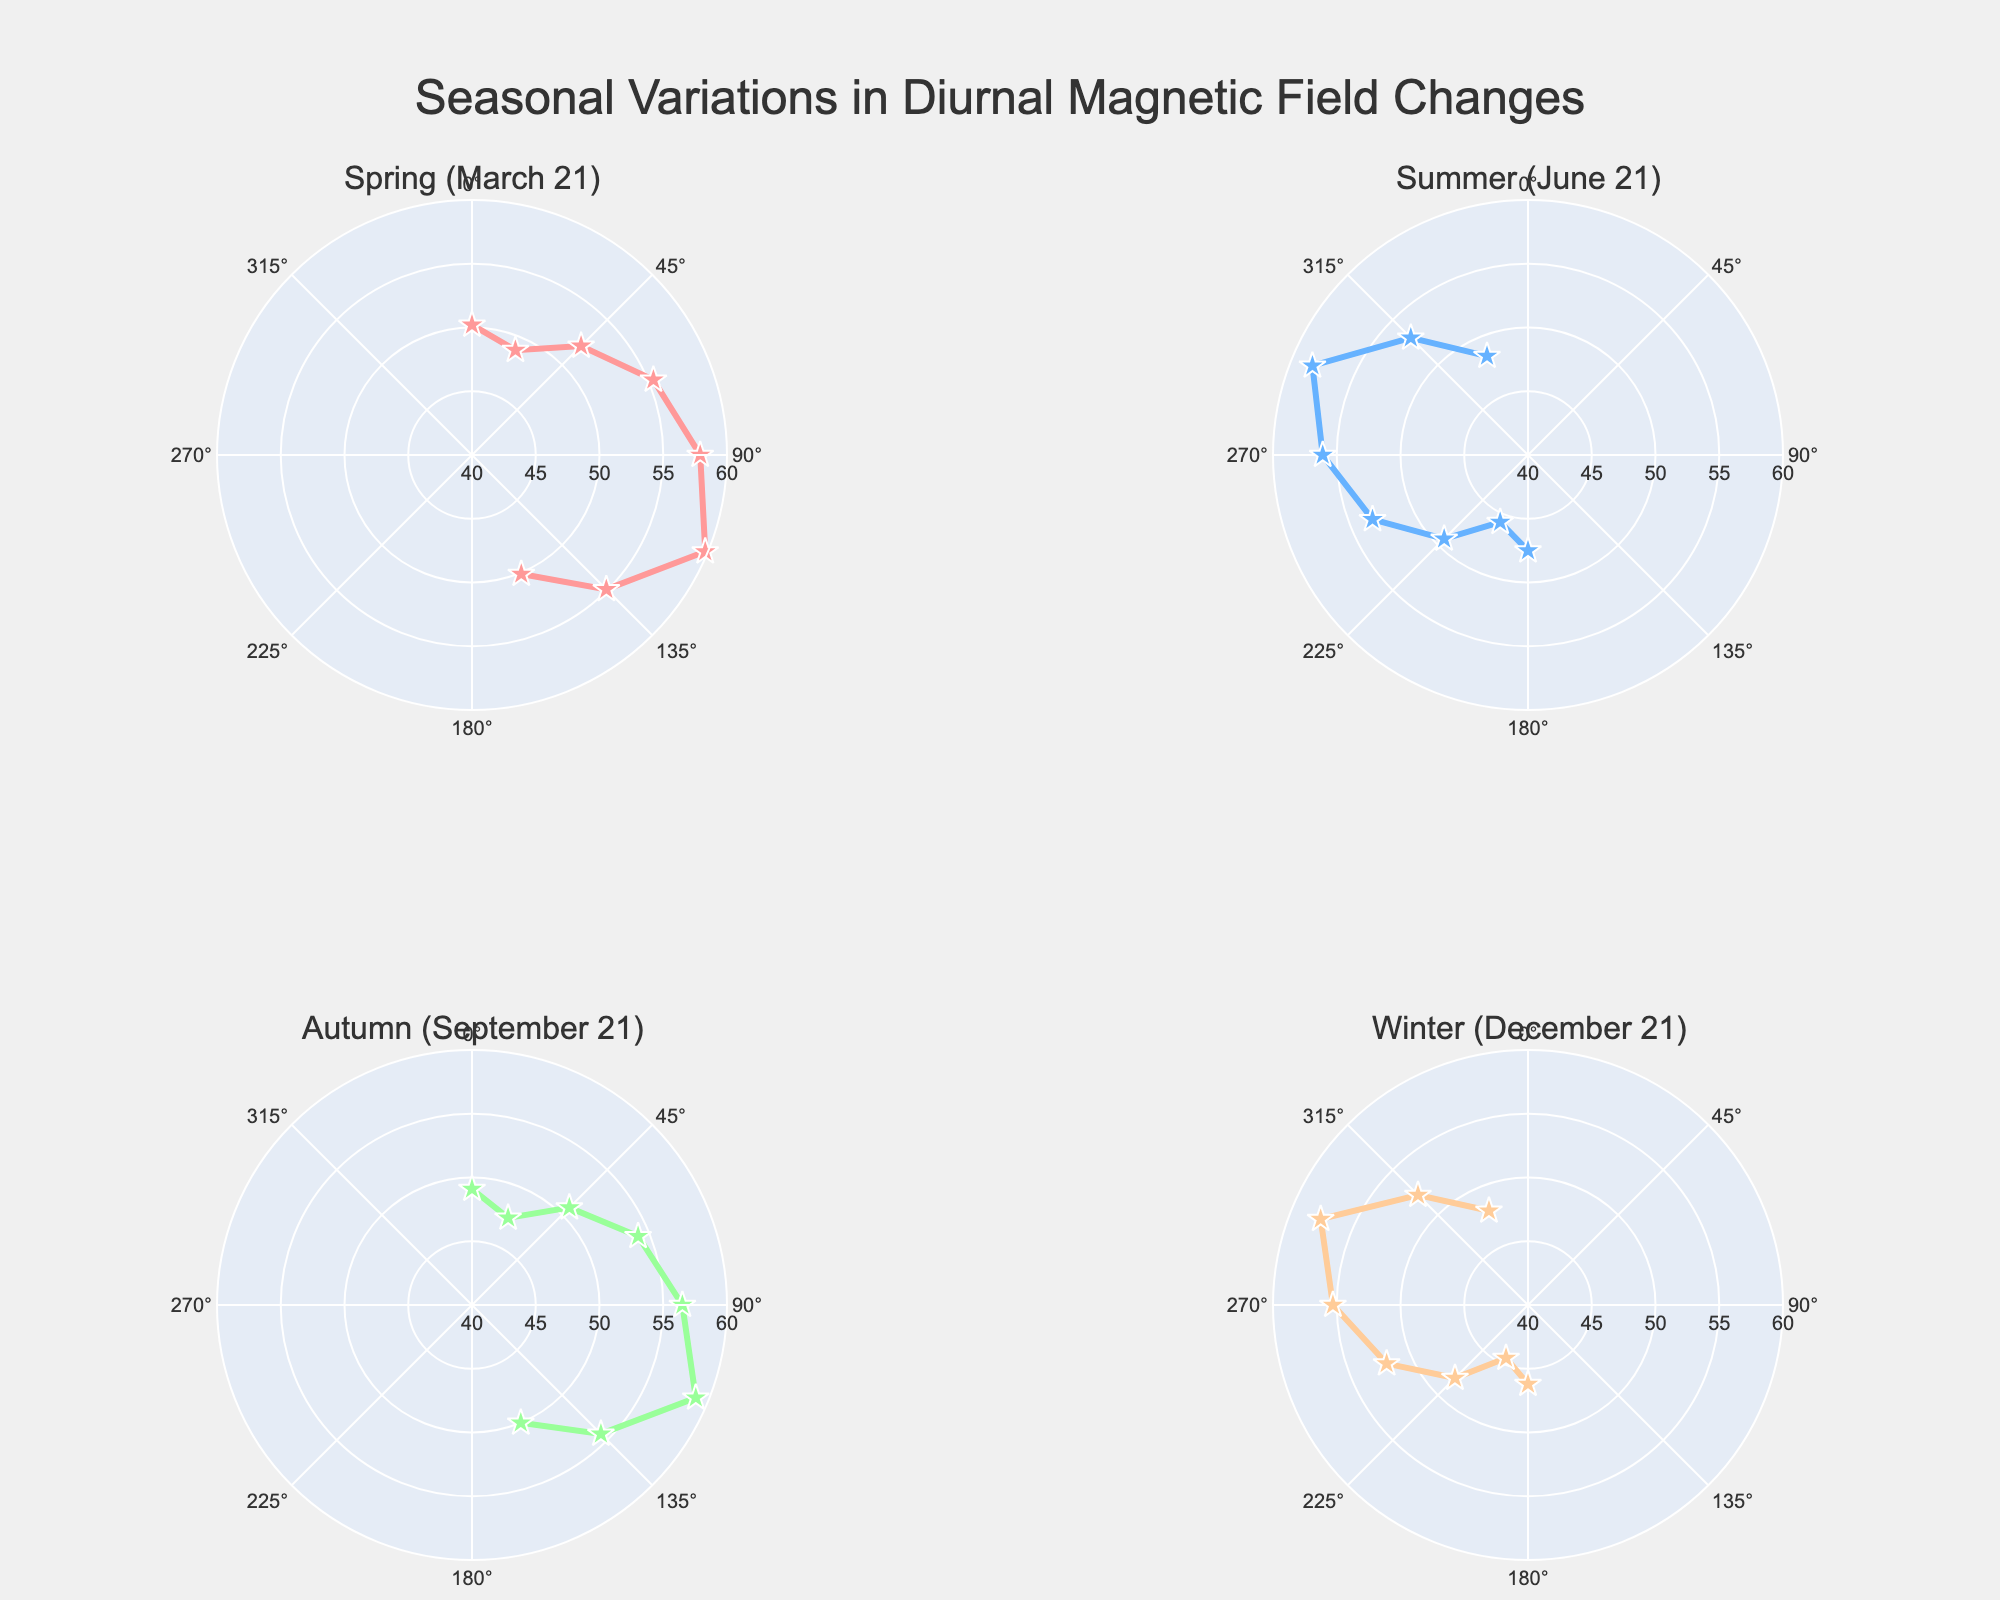How many subplots are there in the figure? The figure contains 4 subplots labeled with the four seasons: Spring, Summer, Autumn, and Winter. This can be identified by observing the titles of each subplot, which correspond to dates March 21, June 21, September 21, and December 21.
Answer: 4 Which season shows the highest maximum magnetic field strength? By examining the radial axis values in each subplot, Summer (June 21) reaches the highest maximum magnetic field strength of approximately 58.3 units.
Answer: Summer What is the difference in maximum magnetic field strength between Summer (June 21) and Winter (December 21)? From the subplots, Summer has a highest value of 58.3 and Winter has a highest value of 57.6. The difference is 58.3 - 57.6 = 0.7.
Answer: 0.7 During which season is the magnetic field strength closest to 50 units around the 03:00 time mark? Evaluating the radial distance in each subplot at around the North-North-East (NNE) direction (roughly equivalent to 03:00), Spring, Autumn, and Winter show values around 48.9, 47.4, and 44.5 respectively, while Summer shows 45.7. Hence, Spring is closest to 50.
Answer: Spring Which direction does the maximum magnetic field strength of Winter occur? Observing the subplot for Winter (December 21), the highest strength of 57.6 units occurs at the West-North-West (WNW) direction.
Answer: WNW What is the average of the maximum magnetic field strengths across all seasons? The maximum values for each season are: Spring 59.8, Summer 58.3, Autumn 59.0, Winter 57.6. Sum them: 59.8 + 58.3 + 59.0 + 57.6 = 234.7. Average = 234.7 / 4 = 58.675.
Answer: 58.675 Which season shows the lowest minimum magnetic field strength, and what is that value? Observing the closest points to the center in each subplot, Winter (December 21) shows the lowest minimum magnetic field strength of 44.5 units.
Answer: Winter, 44.5 Does any season exhibit a magnetic field strength that consistently decreases or increases throughout the day? By following the plotted points in each subplot, all seasons show fluctuations throughout the day rather than a consistent increase or decrease.
Answer: No What is the range of magnetic field strength values for Autumn (September 21)? Observing the subplot for Autumn, the lowest value is 47.4 and the highest is 59.0. The range is 59.0 - 47.4 = 11.6.
Answer: 11.6 Which two adjacent seasons show the most similar pattern and strength of magnetic field changes? Comparing each pair of adjacent subplots, the patterns and strength changes of Spring (March 21) and Autumn (September 21) are the most similar, as both show very close values and directional patterns throughout the day.
Answer: Spring and Autumn 